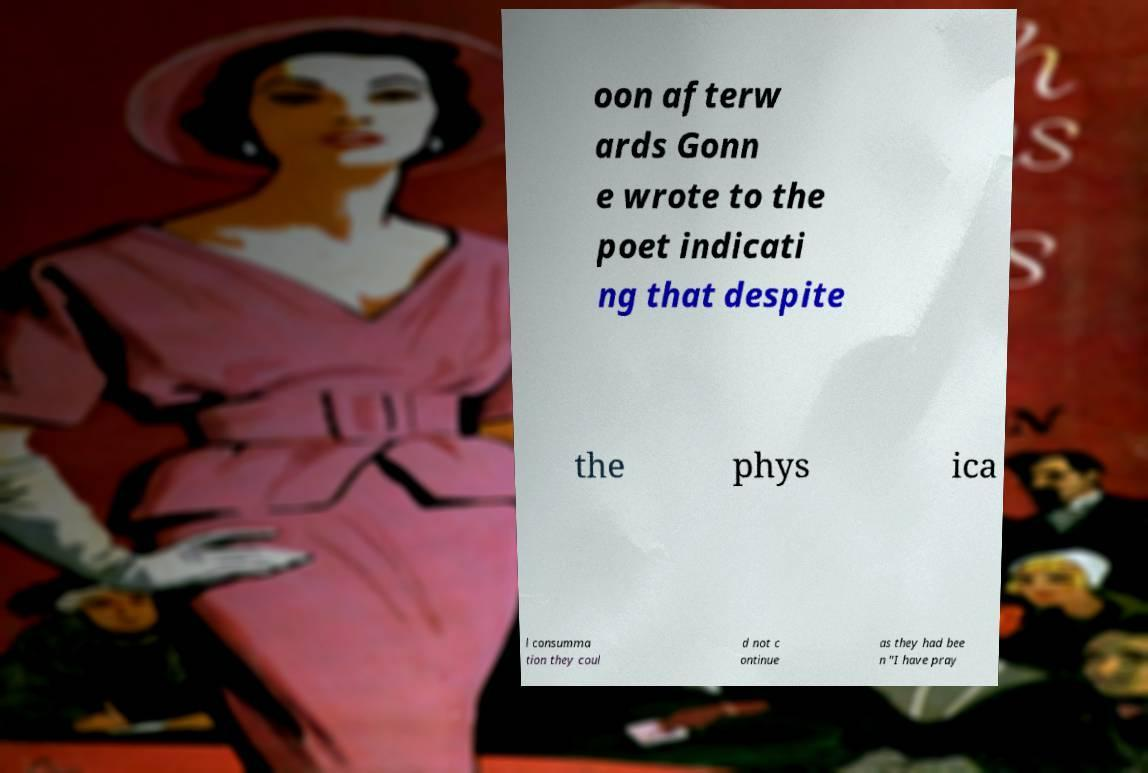Can you accurately transcribe the text from the provided image for me? oon afterw ards Gonn e wrote to the poet indicati ng that despite the phys ica l consumma tion they coul d not c ontinue as they had bee n "I have pray 